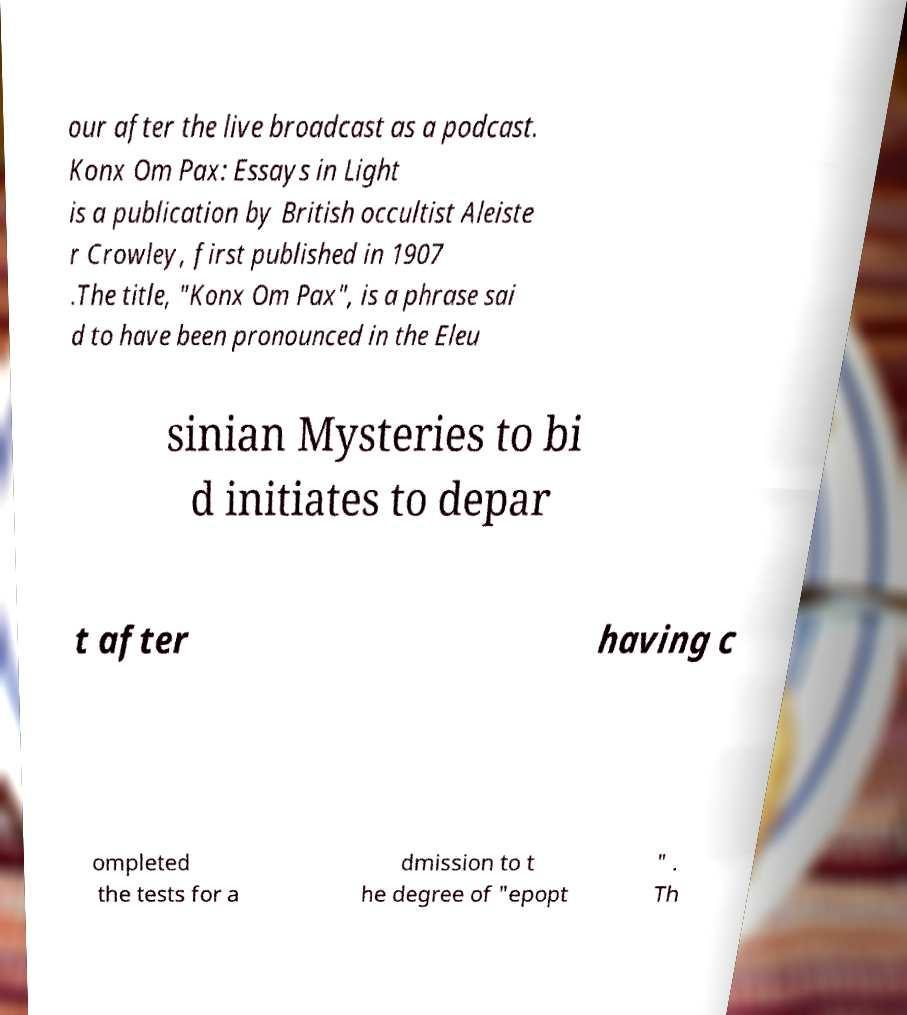Could you assist in decoding the text presented in this image and type it out clearly? our after the live broadcast as a podcast. Konx Om Pax: Essays in Light is a publication by British occultist Aleiste r Crowley, first published in 1907 .The title, "Konx Om Pax", is a phrase sai d to have been pronounced in the Eleu sinian Mysteries to bi d initiates to depar t after having c ompleted the tests for a dmission to t he degree of "epopt " . Th 